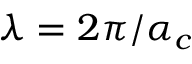<formula> <loc_0><loc_0><loc_500><loc_500>\lambda = 2 \pi / \alpha _ { c }</formula> 